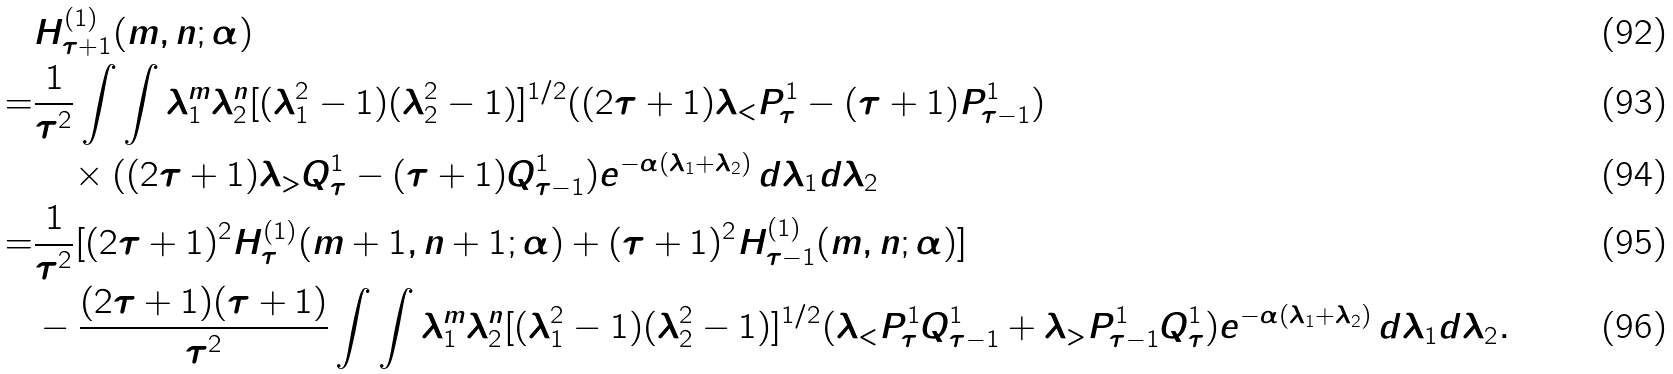Convert formula to latex. <formula><loc_0><loc_0><loc_500><loc_500>& H ^ { ( 1 ) } _ { \tau + 1 } ( m , n ; \alpha ) \\ = & \frac { 1 } { \tau ^ { 2 } } \int \int \lambda _ { 1 } ^ { m } \lambda _ { 2 } ^ { n } [ ( \lambda _ { 1 } ^ { 2 } - 1 ) ( \lambda _ { 2 } ^ { 2 } - 1 ) ] ^ { 1 / 2 } ( ( 2 \tau + 1 ) \lambda _ { < } P ^ { 1 } _ { \tau } - ( \tau + 1 ) P ^ { 1 } _ { \tau - 1 } ) \\ & \quad \times ( ( 2 \tau + 1 ) \lambda _ { > } Q ^ { 1 } _ { \tau } - ( \tau + 1 ) Q ^ { 1 } _ { \tau - 1 } ) e ^ { - \alpha ( \lambda _ { 1 } + \lambda _ { 2 } ) } \, d \lambda _ { 1 } d \lambda _ { 2 } \\ = & \frac { 1 } { \tau ^ { 2 } } [ ( 2 \tau + 1 ) ^ { 2 } H ^ { ( 1 ) } _ { \tau } ( m + 1 , n + 1 ; \alpha ) + ( \tau + 1 ) ^ { 2 } H ^ { ( 1 ) } _ { \tau - 1 } ( m , n ; \alpha ) ] \\ & - \frac { ( 2 \tau + 1 ) ( \tau + 1 ) } { \tau ^ { 2 } } \int \int \lambda _ { 1 } ^ { m } \lambda _ { 2 } ^ { n } [ ( \lambda _ { 1 } ^ { 2 } - 1 ) ( \lambda _ { 2 } ^ { 2 } - 1 ) ] ^ { 1 / 2 } ( \lambda _ { < } P ^ { 1 } _ { \tau } Q ^ { 1 } _ { \tau - 1 } + \lambda _ { > } P ^ { 1 } _ { \tau - 1 } Q ^ { 1 } _ { \tau } ) e ^ { - \alpha ( \lambda _ { 1 } + \lambda _ { 2 } ) } \, d \lambda _ { 1 } d \lambda _ { 2 } .</formula> 